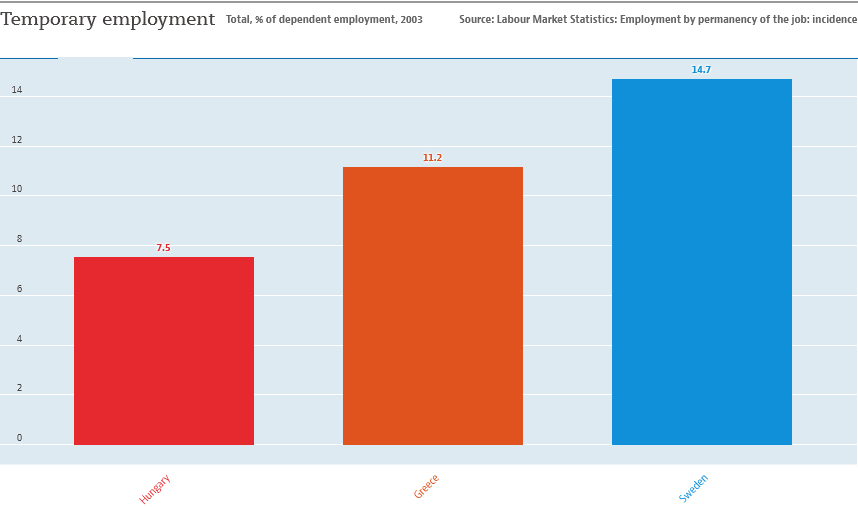Give some essential details in this illustration. There are three color bars in the graph. The largest two bars have an add up value of 25.9. 